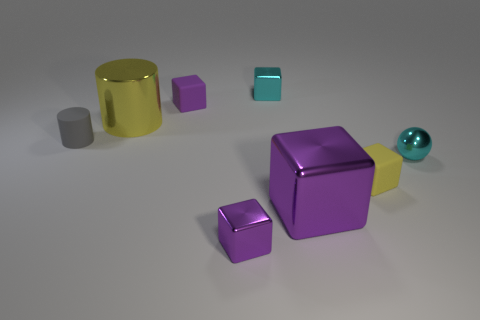Subtract all purple cubes. How many were subtracted if there are1purple cubes left? 2 Subtract all big purple cubes. How many cubes are left? 4 Subtract all spheres. How many objects are left? 7 Subtract 1 blocks. How many blocks are left? 4 Subtract all green blocks. Subtract all green cylinders. How many blocks are left? 5 Subtract all yellow cylinders. How many cyan cubes are left? 1 Subtract all small purple objects. Subtract all yellow cylinders. How many objects are left? 5 Add 8 metallic cylinders. How many metallic cylinders are left? 9 Add 8 tiny yellow metallic cubes. How many tiny yellow metallic cubes exist? 8 Add 1 small gray metallic objects. How many objects exist? 9 